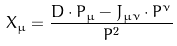Convert formula to latex. <formula><loc_0><loc_0><loc_500><loc_500>X _ { \mu } = \frac { D \cdot P _ { \mu } - J _ { \mu \nu } \cdot P ^ { \nu } } { P ^ { 2 } }</formula> 